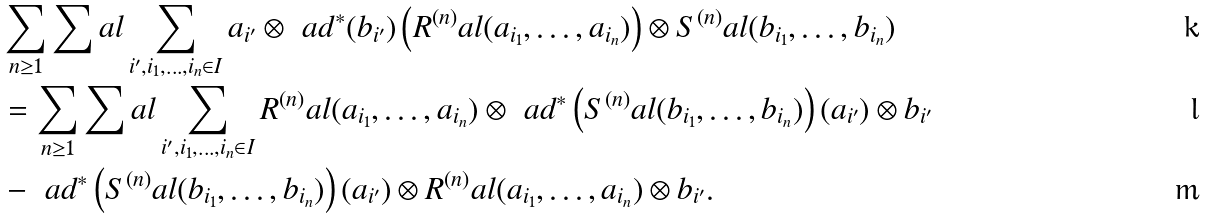Convert formula to latex. <formula><loc_0><loc_0><loc_500><loc_500>& \sum _ { n \geq 1 } \sum _ { \ } a l \sum _ { i ^ { \prime } , i _ { 1 } , \dots , i _ { n } \in I } a _ { i ^ { \prime } } \otimes \ a d ^ { * } ( b _ { i ^ { \prime } } ) \left ( R ^ { ( n ) } _ { \ } a l ( a _ { i _ { 1 } } , \dots , a _ { i _ { n } } ) \right ) \otimes S ^ { ( n ) } _ { \ } a l ( b _ { i _ { 1 } } , \dots , b _ { i _ { n } } ) \\ & = \sum _ { n \geq 1 } \sum _ { \ } a l \sum _ { i ^ { \prime } , i _ { 1 } , \dots , i _ { n } \in I } R ^ { ( n ) } _ { \ } a l ( a _ { i _ { 1 } } , \dots , a _ { i _ { n } } ) \otimes \ a d ^ { * } \left ( S ^ { ( n ) } _ { \ } a l ( b _ { i _ { 1 } } , \dots , b _ { i _ { n } } ) \right ) ( a _ { i ^ { \prime } } ) \otimes b _ { i ^ { \prime } } \\ & - \ a d ^ { * } \left ( S ^ { ( n ) } _ { \ } a l ( b _ { i _ { 1 } } , \dots , b _ { i _ { n } } ) \right ) ( a _ { i ^ { \prime } } ) \otimes R ^ { ( n ) } _ { \ } a l ( a _ { i _ { 1 } } , \dots , a _ { i _ { n } } ) \otimes b _ { i ^ { \prime } } .</formula> 